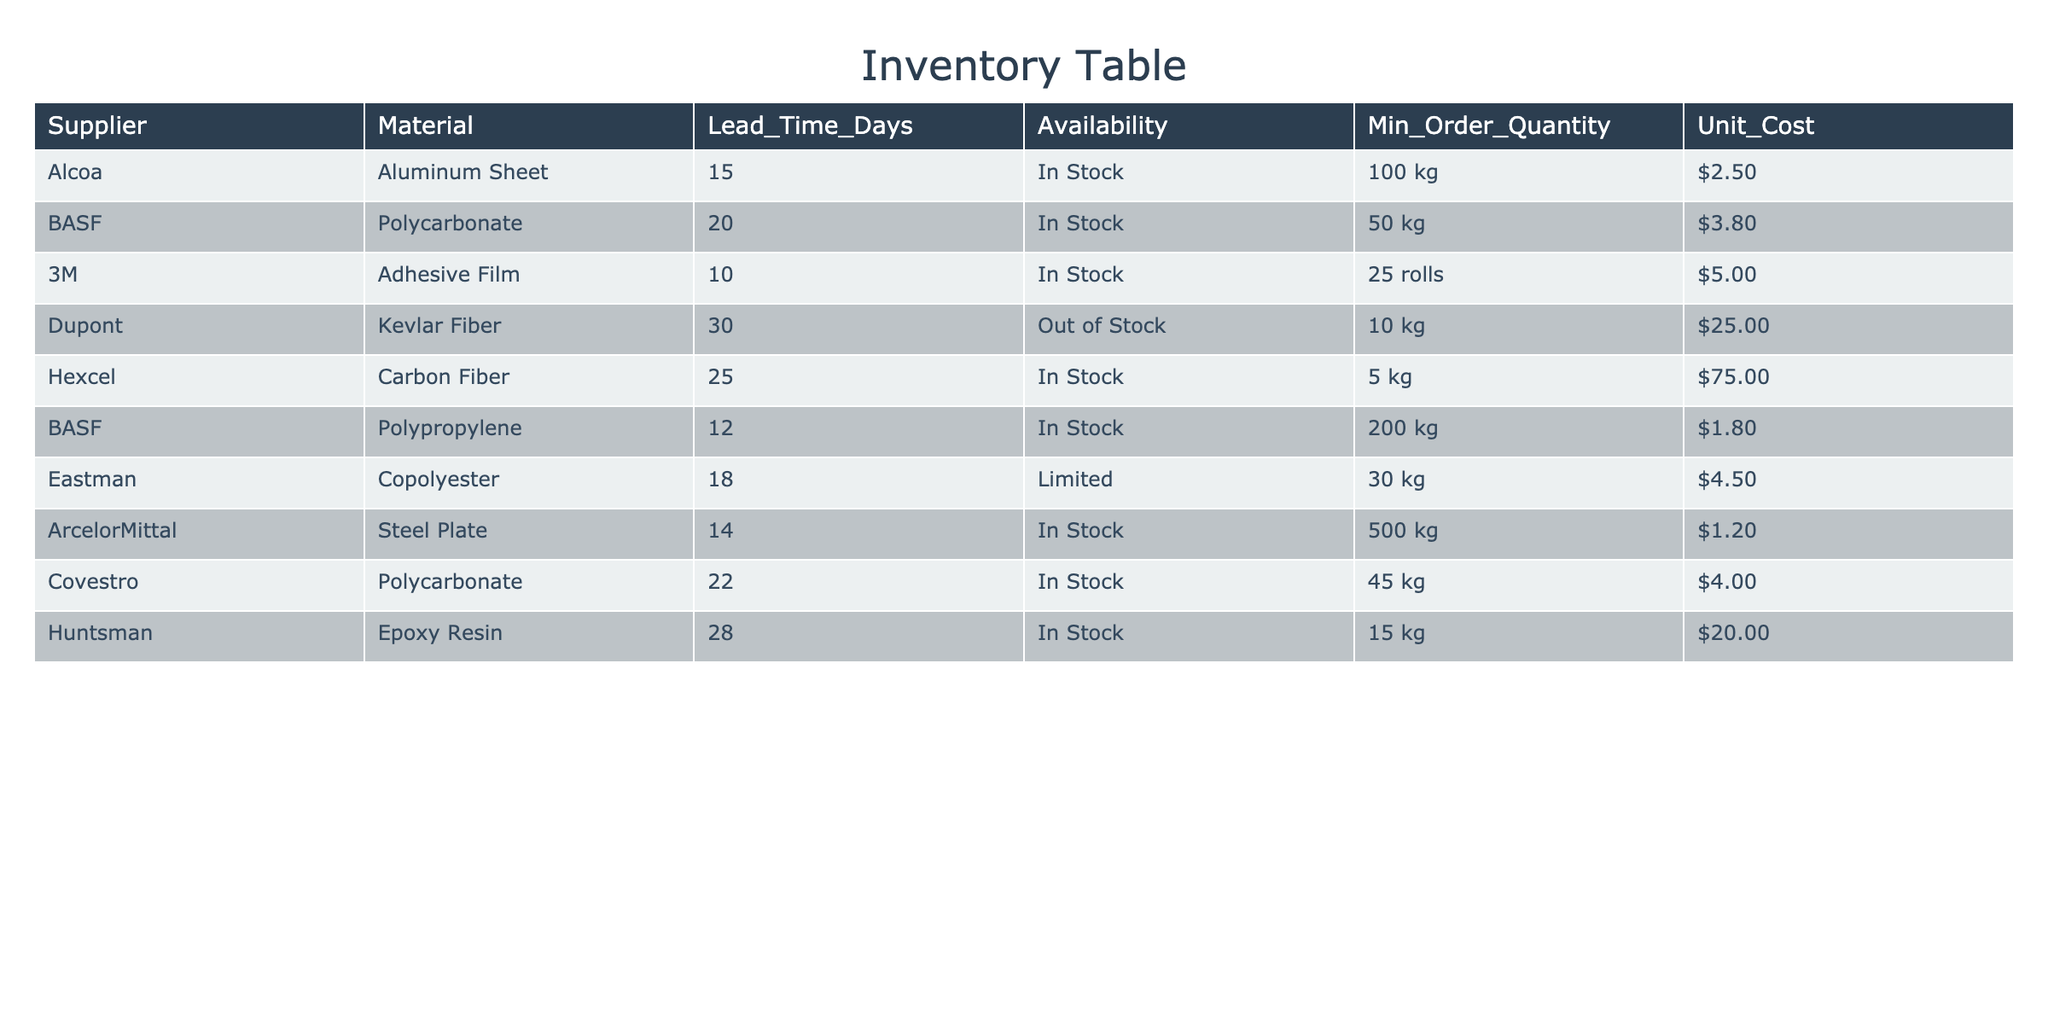What is the lead time for the Aluminum Sheet supplied by Alcoa? The lead time for the Aluminum Sheet, as specified in the table, is located in the 'Lead_Time_Days' column corresponding to Alcoa. It shows 15 days.
Answer: 15 days Which supplier offers the lowest unit cost for their material? By examining the 'Unit_Cost' column, we can compare the values. The lowest unit cost is $1.20, offered by ArcelorMittal for Steel Plate.
Answer: $1.20 Are there any materials that are currently out of stock? Looking at the 'Availability' column, we check for the term "Out of Stock." The only material that meets this criterion is Kevlar Fiber from Dupont.
Answer: Yes What is the average lead time for the materials that are currently in stock? We first identify the materials that are "In Stock", which includes Aluminum Sheet, Polycarbonate, Adhesive Film, Carbon Fiber, Polypropylene, Steel Plate, and Epoxy Resin, totaling 7 materials. We then sum their lead times (15 + 20 + 10 + 25 + 12 + 14 + 28) = 134 days. The average is 134/7 = 19.14 days.
Answer: 19.14 days Which material has the highest minimum order quantity? To find the material with the highest minimum order quantity, we review the 'Min_Order_Quantity' column. The maximum value is 500 kg for Steel Plate from ArcelorMittal.
Answer: 500 kg If I wanted to order 100 kg of Polypropylene from BASF, would I be able to do so? We check the 'Min_Order_Quantity' for Polypropylene from BASF, which is 200 kg. Since 100 kg is less than the minimum order requirement, it is not possible to place that order.
Answer: No How many suppliers provide materials with a lead time greater than 20 days? In the 'Lead_Time_Days' column, we note the materials with lead times greater than 20 days: Dupont (30), Hexcel (25), and Huntsman (28). This gives us a total of 3 suppliers with such lead times.
Answer: 3 suppliers What is the cost difference between the most expensive material and the least expensive material? To find this difference, we identify the highest unit cost ($75.00 for Carbon Fiber, Hexcel) and the lowest unit cost ($1.20 for Steel Plate, ArcelorMittal). The difference is $75.00 - $1.20 = $73.80.
Answer: $73.80 Are there any limited availability materials in the table? We check the 'Availability' column for the term "Limited." The only material that is labeled as limited is Copolyester from Eastman.
Answer: Yes 